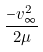<formula> <loc_0><loc_0><loc_500><loc_500>\frac { - v _ { \infty } ^ { 2 } } { 2 \mu }</formula> 